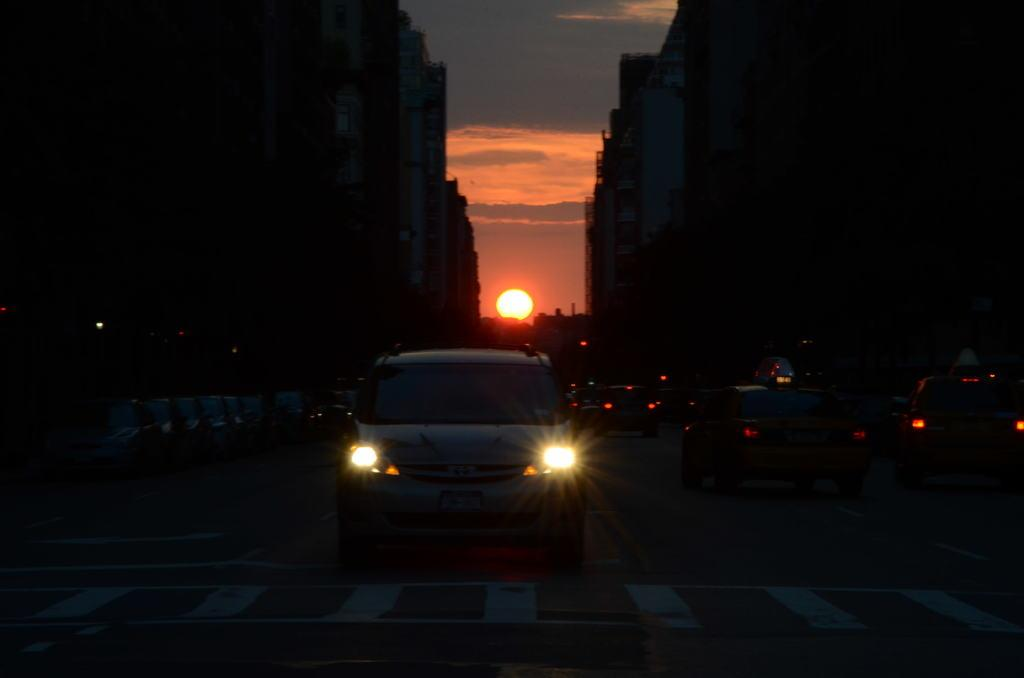What type of structures can be seen in the image? There are buildings in the image. What else is present in the image besides buildings? There are vehicles and lights visible in the image. What can be seen in the sky in the image? The sky is visible in the image, and the sun is also visible. How would you describe the overall lighting in the image? The image is described as dark. What type of glove is the farmer wearing in the image? There is no farmer or glove present in the image. What type of rail is visible in the image? There is no rail present in the image. 